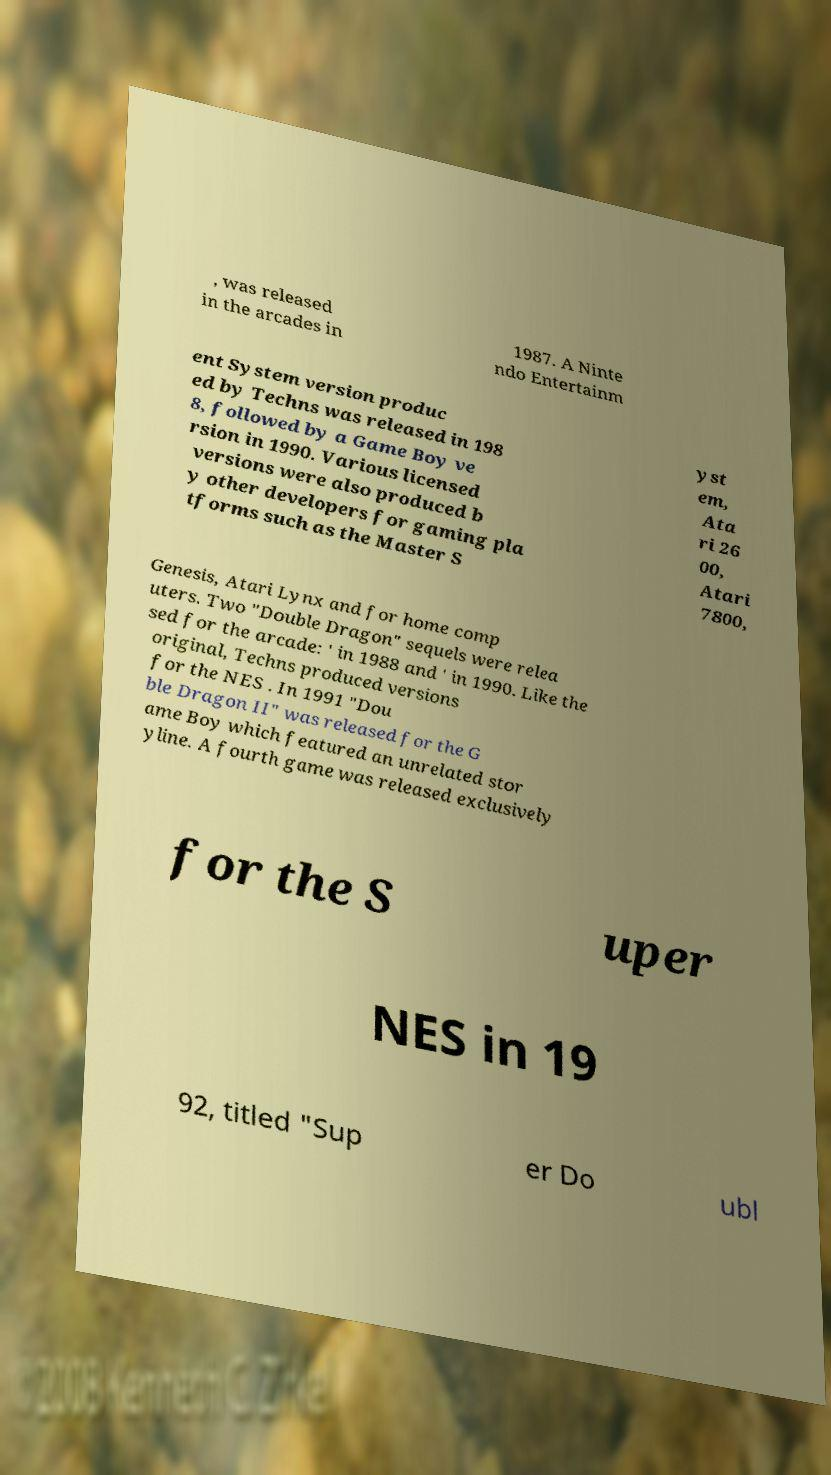There's text embedded in this image that I need extracted. Can you transcribe it verbatim? , was released in the arcades in 1987. A Ninte ndo Entertainm ent System version produc ed by Techns was released in 198 8, followed by a Game Boy ve rsion in 1990. Various licensed versions were also produced b y other developers for gaming pla tforms such as the Master S yst em, Ata ri 26 00, Atari 7800, Genesis, Atari Lynx and for home comp uters. Two "Double Dragon" sequels were relea sed for the arcade: ' in 1988 and ' in 1990. Like the original, Techns produced versions for the NES . In 1991 "Dou ble Dragon II" was released for the G ame Boy which featured an unrelated stor yline. A fourth game was released exclusively for the S uper NES in 19 92, titled "Sup er Do ubl 